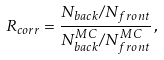<formula> <loc_0><loc_0><loc_500><loc_500>R _ { c o r r } = \frac { N _ { b a c k } / N _ { f r o n t } } { N _ { b a c k } ^ { M C } / N _ { f r o n t } ^ { M C } } \, ,</formula> 